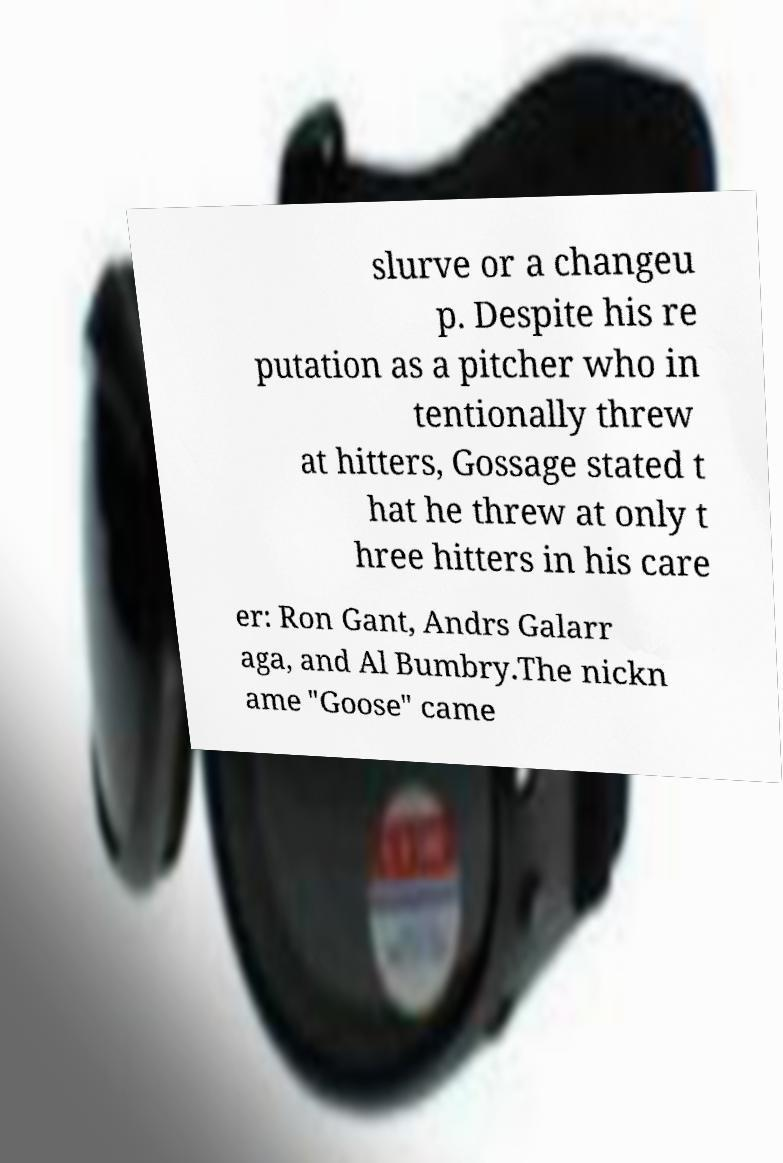Please read and relay the text visible in this image. What does it say? slurve or a changeu p. Despite his re putation as a pitcher who in tentionally threw at hitters, Gossage stated t hat he threw at only t hree hitters in his care er: Ron Gant, Andrs Galarr aga, and Al Bumbry.The nickn ame "Goose" came 